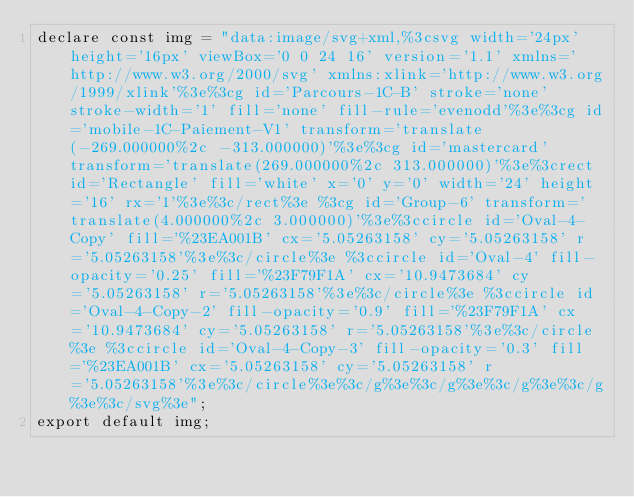Convert code to text. <code><loc_0><loc_0><loc_500><loc_500><_TypeScript_>declare const img = "data:image/svg+xml,%3csvg width='24px' height='16px' viewBox='0 0 24 16' version='1.1' xmlns='http://www.w3.org/2000/svg' xmlns:xlink='http://www.w3.org/1999/xlink'%3e%3cg id='Parcours-1C-B' stroke='none' stroke-width='1' fill='none' fill-rule='evenodd'%3e%3cg id='mobile-1C-Paiement-V1' transform='translate(-269.000000%2c -313.000000)'%3e%3cg id='mastercard' transform='translate(269.000000%2c 313.000000)'%3e%3crect id='Rectangle' fill='white' x='0' y='0' width='24' height='16' rx='1'%3e%3c/rect%3e %3cg id='Group-6' transform='translate(4.000000%2c 3.000000)'%3e%3ccircle id='Oval-4-Copy' fill='%23EA001B' cx='5.05263158' cy='5.05263158' r='5.05263158'%3e%3c/circle%3e %3ccircle id='Oval-4' fill-opacity='0.25' fill='%23F79F1A' cx='10.9473684' cy='5.05263158' r='5.05263158'%3e%3c/circle%3e %3ccircle id='Oval-4-Copy-2' fill-opacity='0.9' fill='%23F79F1A' cx='10.9473684' cy='5.05263158' r='5.05263158'%3e%3c/circle%3e %3ccircle id='Oval-4-Copy-3' fill-opacity='0.3' fill='%23EA001B' cx='5.05263158' cy='5.05263158' r='5.05263158'%3e%3c/circle%3e%3c/g%3e%3c/g%3e%3c/g%3e%3c/g%3e%3c/svg%3e";
export default img;
</code> 